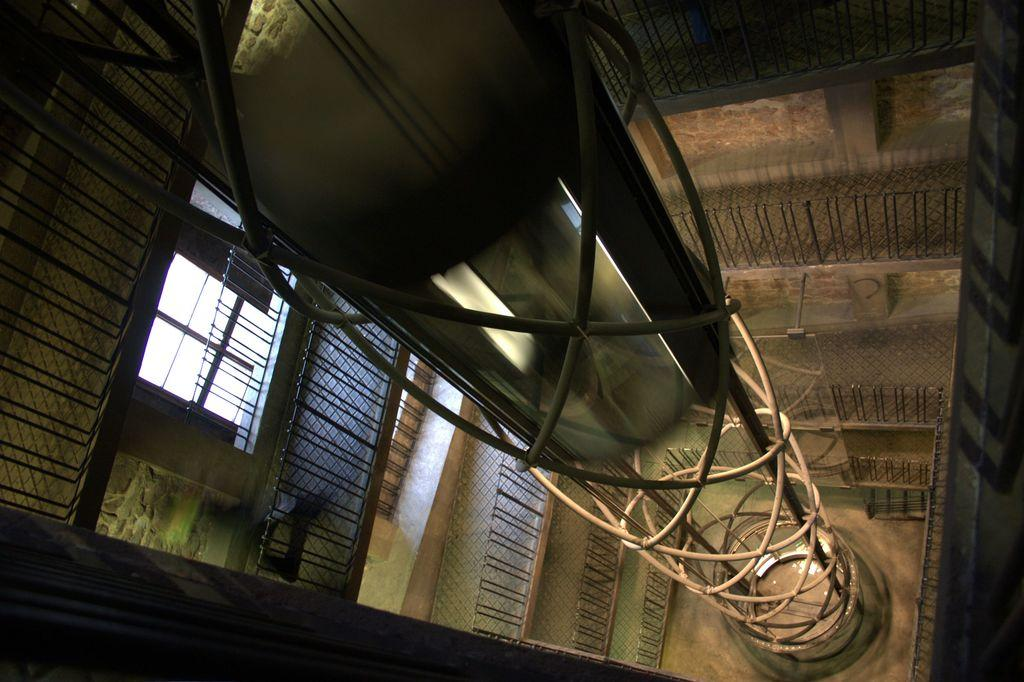What is located in the center of the image? There is a pipe and iron rods in the center of the image. What can be seen in the background of the image? There are windows and a wall in the background of the image. What type of lace can be seen hanging from the edge of the pipe in the image? There is no lace present in the image, and the pipe does not have an edge. 